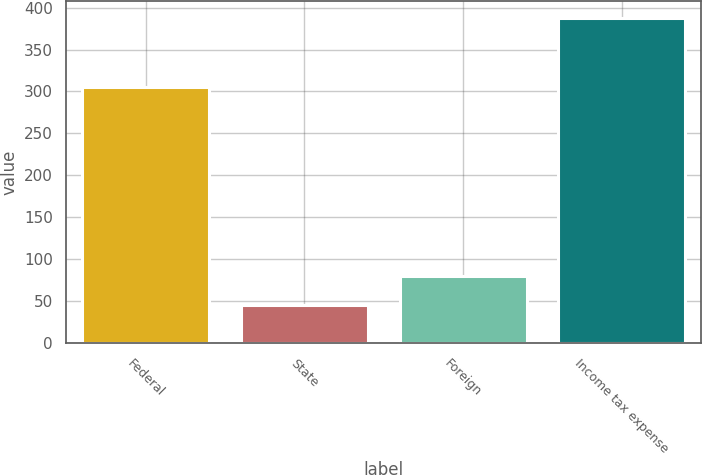<chart> <loc_0><loc_0><loc_500><loc_500><bar_chart><fcel>Federal<fcel>State<fcel>Foreign<fcel>Income tax expense<nl><fcel>305<fcel>46<fcel>80.2<fcel>388<nl></chart> 